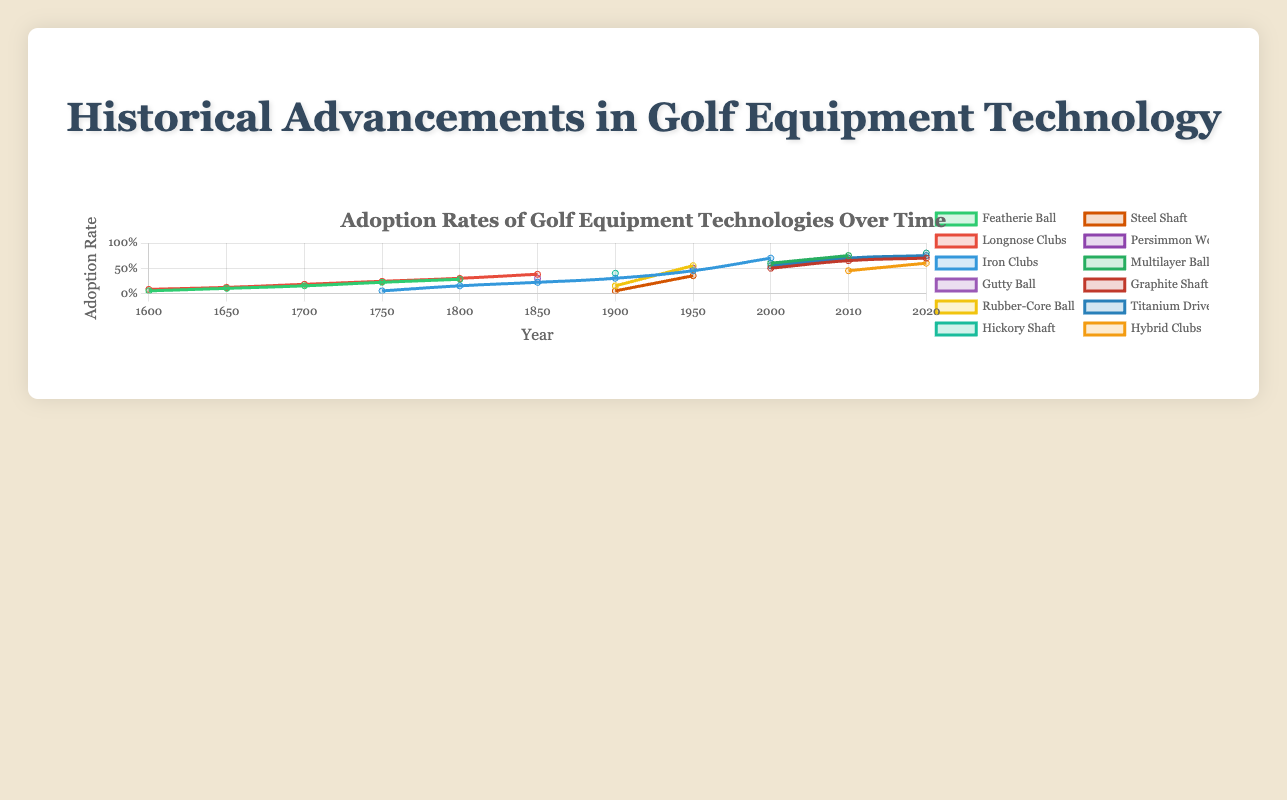What was the adoption rate of the Featherie Ball in 1750? The Featherie Ball adoption rate can be read directly from the plot for the year 1750.
Answer: 0.22 Which technology had the highest adoption rate in 1950? By visually comparing the heights of the lines in 1950, we can see that the "Rubber-Core Ball" had the highest adoption rate.
Answer: Rubber-Core Ball How did the adoption rate of Longnose Clubs change from 1800 to 1850? The adoption rate of Longnose Clubs in 1800 is 0.30 and in 1850 is 0.38, so the change is the difference between these values: 0.38 - 0.30.
Answer: 0.08 Which new technology appeared in the year 1900, and what was its initial adoption rate? The "Hickory Shaft" and "Steel Shaft" technologies appeared in 1900 based on the plot, with initial adoption rates of 0.40 and 0.05, respectively.
Answer: Hickory Shaft (0.40), Steel Shaft (0.05) Compare the adoption rates of Iron Clubs and Graphite Shaft in 2000. The adoption rate of Iron Clubs in 2000 is 0.70, and for the Graphite Shaft, it is 0.50. Iron Clubs have a higher adoption rate.
Answer: Iron Clubs What is the year when the Titanium Driver adoption rate surpassed 50%? The Titanium Driver adoption rate can be traced in the plot, and we see it surpasses 50% in the year 2010.
Answer: 2010 Calculate the average adoption rate of the Multilayer Ball over the years it was tracked in the plot. The adoption rates available for the Multilayer Ball are 0.60 in 2000 and 0.75 in 2010. The average can be calculated as (0.60 + 0.75) / 2.
Answer: 0.675 Which technology had the most significant increase in adoption rate between two successive years, and what was the increase? By inspecting the plot, the "Rubber-Core Ball" had the most significant increase from 1900 (0.15) to 1950 (0.55), which is a difference of 0.55 - 0.15.
Answer: Rubber-Core Ball (0.40) What was the adoption rate of Hybrid Clubs in 2010 and 2020? The adoption rate of Hybrid Clubs in 2010 is 0.45 and in 2020 is 0.60, as per the plot data.
Answer: 0.45 (2010), 0.60 (2020) 